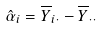Convert formula to latex. <formula><loc_0><loc_0><loc_500><loc_500>\hat { \alpha } _ { i } = \overline { Y } _ { i \cdot } - \overline { Y } _ { \cdot \cdot }</formula> 